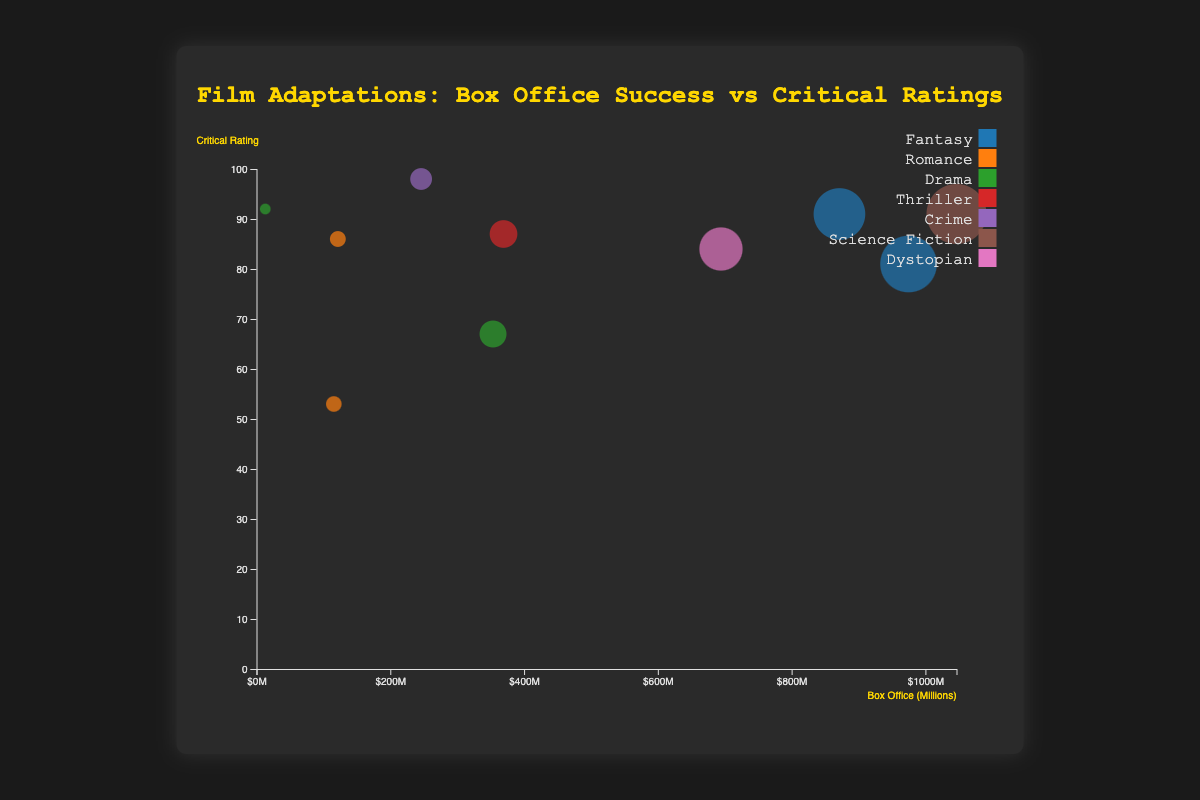How many genres are represented in the chart? By looking at the legend, we can count the distinct colors, each representing a genre. There are 6 unique genres: Fantasy, Romance, Drama, Thriller, Crime, and Science Fiction.
Answer: 6 Which film has the highest box office earnings? By identifying the largest bubble on the x-axis, representing box office earnings, we see that "Jurassic Park" sits at the farthest right with $1046.5 million.
Answer: Jurassic Park Which genre has the film with the highest critical rating? Checking the highest position on the y-axis, we see "The Godfather" at the top with a 98 critical rating, labeled as Crime in the legend.
Answer: Crime What is the combined box office total of the two highest-grossing films in the chart? The two films with the furthest right positions are "Jurassic Park" ($1046.5 million) and "Harry Potter and the Philosopher's Stone" ($974.8 million). Sum these values: 1046.5 + 974.8 = 2021.3 million.
Answer: $2021.3 million Which genre appears most frequently in the chart? By counting the occurrences of each genre label found in the tooltip or legend, we observe "Drama" and "Fantasy" each appear twice, more frequently than any other genre.
Answer: Drama and Fantasy What's the average critical rating for Romance films? The films labeled as Romance are "Pride and Prejudice" (86) and "The Notebook" (53). Calculate the average: (86 + 53) / 2 = 69.5.
Answer: 69.5 Compare the box office earnings of "Gone Girl" and "The Great Gatsby". Which film earned more and by how much? Finding their specific positions, we see "Gone Girl" ($369.3 million) and "The Great Gatsby" ($353.6 million). Subtract to find the difference: 369.3 - 353.6 = 15.7 million, with "Gone Girl" earning more.
Answer: Gone Girl by $15.7 million Are there any films that have both a critical rating greater than 90 and box office earnings over $800 million? Films satisfying both conditions are identified by their high y-axis (rating) and far right x-axis (earnings). "Jurassic Park" has a rating of 91 and earnings of $1046.5 million, matching the criteria.
Answer: Jurassic Park Which film has the lowest box office earnings and what is its critical rating? The smallest bubble on the x-axis near the origin represents "To Kill a Mockingbird" with $13.1 million in earnings and a critical rating of 92.
Answer: To Kill a Mockingbird, 92 